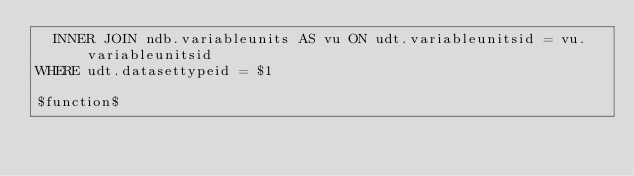Convert code to text. <code><loc_0><loc_0><loc_500><loc_500><_SQL_>  INNER JOIN ndb.variableunits AS vu ON udt.variableunitsid = vu.variableunitsid
WHERE udt.datasettypeid = $1

$function$
</code> 